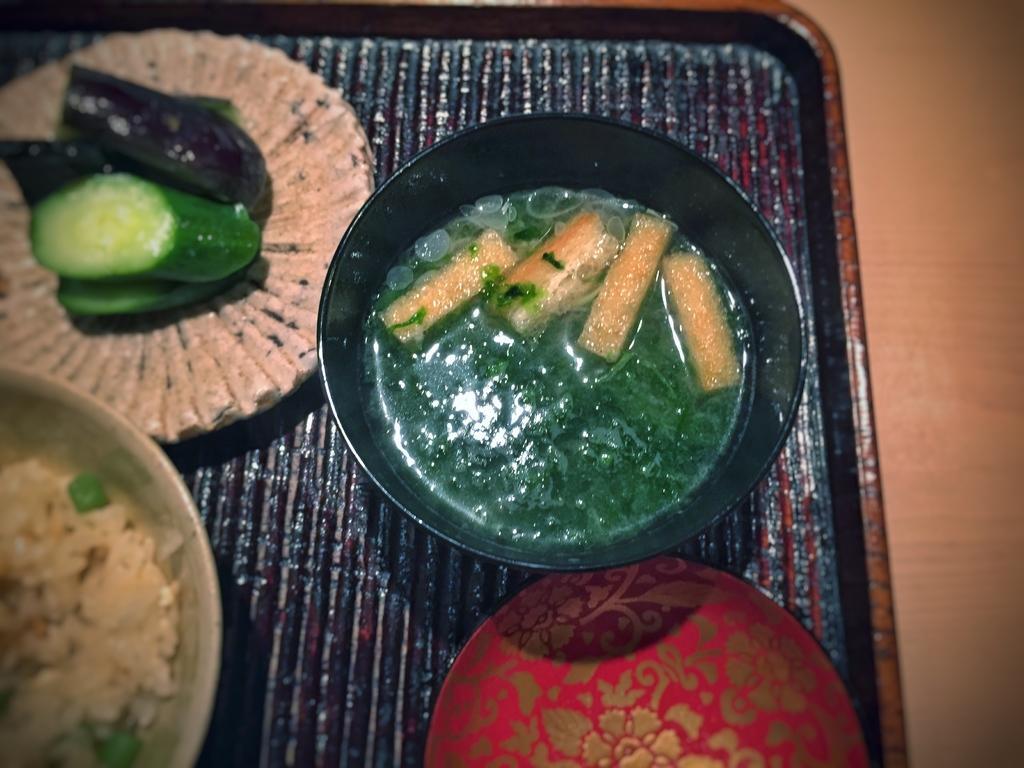Can you describe this image briefly? In this image I can see a cream colored surface and on it I can see a black colored tray and on the tray I can see a black colored bowl in which I can see green colored liquid and few brown colored objects. I can see a red and gold colored plate, a bowl with rice in it and a plate with green colored food item in it. 